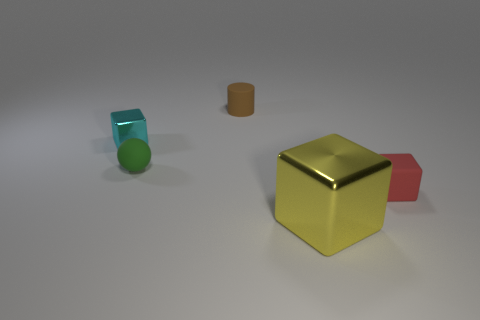Is the number of green matte things greater than the number of matte things?
Ensure brevity in your answer.  No. There is a brown cylinder that is the same size as the green ball; what material is it?
Keep it short and to the point. Rubber. Is the small cyan thing made of the same material as the yellow thing?
Make the answer very short. Yes. How many small spheres are the same material as the green thing?
Ensure brevity in your answer.  0. How many things are either metal objects that are on the right side of the rubber cylinder or small things that are right of the cyan thing?
Your response must be concise. 4. Are there more tiny red things that are to the left of the small brown cylinder than small green matte things that are on the right side of the big yellow metallic cube?
Keep it short and to the point. No. What color is the small cube in front of the green rubber sphere?
Your answer should be very brief. Red. Is there a cyan metallic object that has the same shape as the yellow metal thing?
Ensure brevity in your answer.  Yes. What number of gray objects are either small metallic objects or matte spheres?
Give a very brief answer. 0. Are there any other objects that have the same size as the brown matte object?
Offer a very short reply. Yes. 